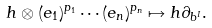Convert formula to latex. <formula><loc_0><loc_0><loc_500><loc_500>h \otimes ( e _ { 1 } ) ^ { p _ { 1 } } \cdots ( e _ { n } ) ^ { p _ { n } } \mapsto h \partial _ { b ^ { I } } .</formula> 